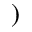Convert formula to latex. <formula><loc_0><loc_0><loc_500><loc_500>)</formula> 